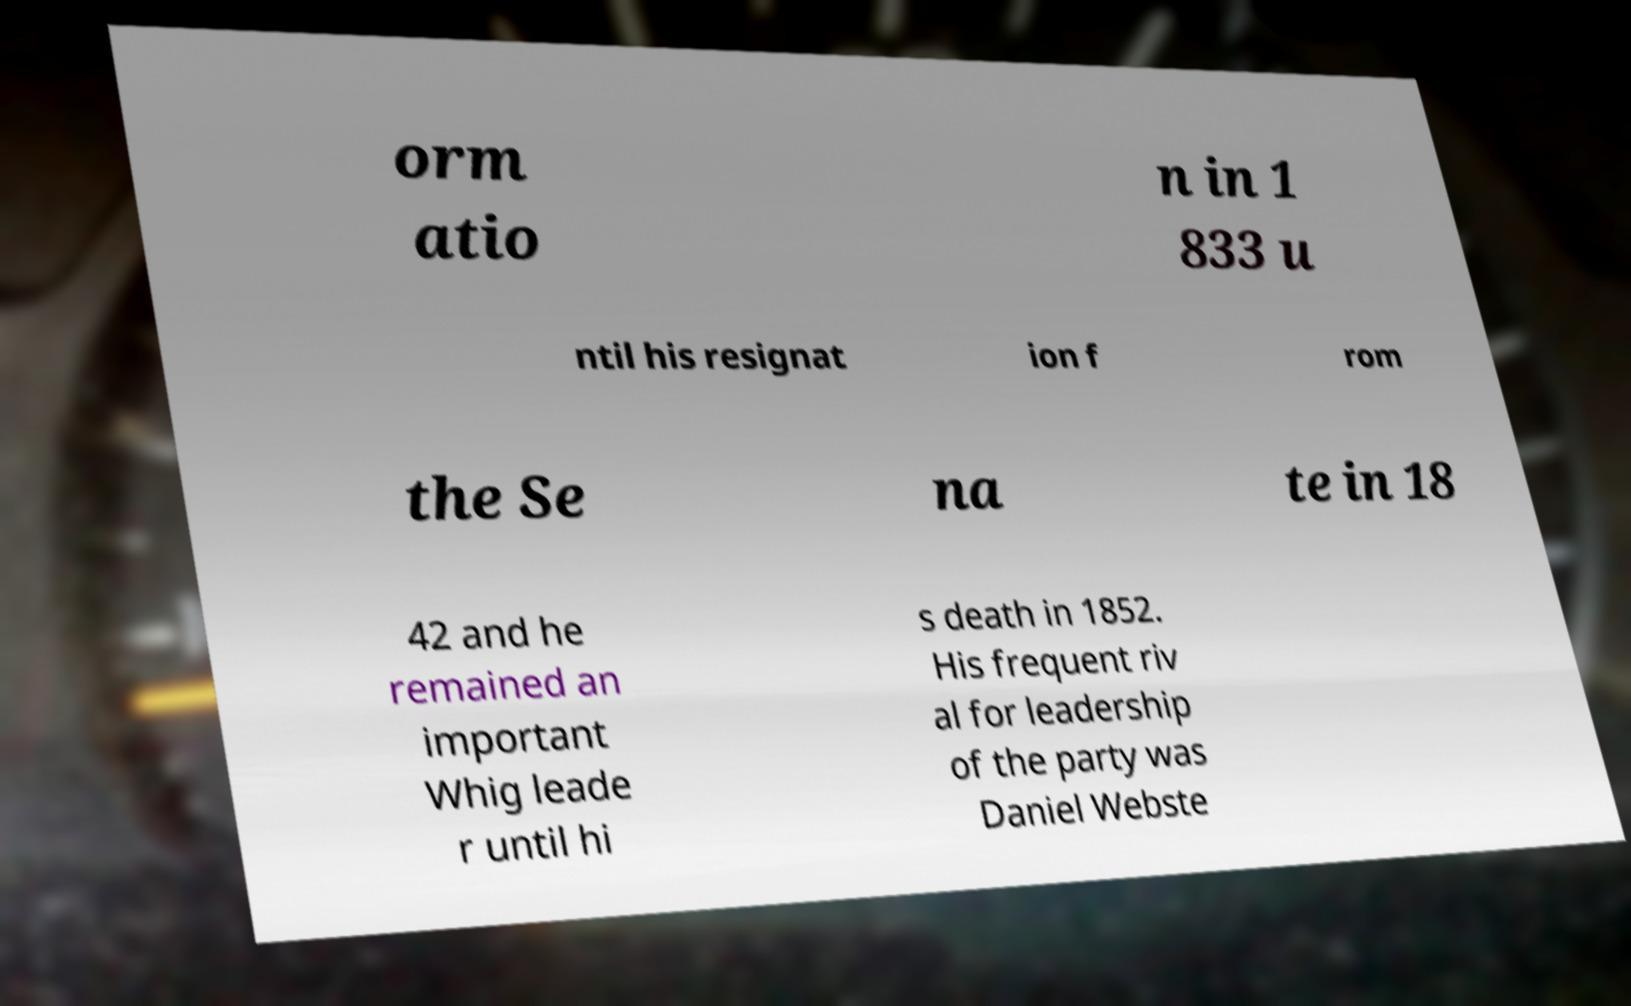There's text embedded in this image that I need extracted. Can you transcribe it verbatim? orm atio n in 1 833 u ntil his resignat ion f rom the Se na te in 18 42 and he remained an important Whig leade r until hi s death in 1852. His frequent riv al for leadership of the party was Daniel Webste 